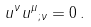<formula> <loc_0><loc_0><loc_500><loc_500>u ^ { \nu } { u ^ { \mu } } _ { ; \nu } = 0 \, .</formula> 